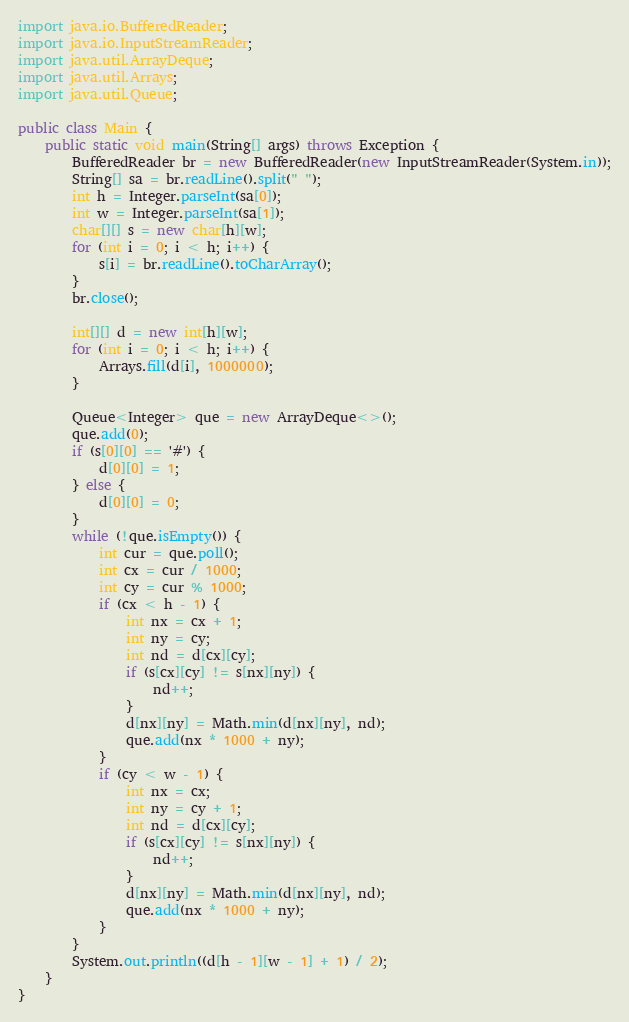Convert code to text. <code><loc_0><loc_0><loc_500><loc_500><_Java_>import java.io.BufferedReader;
import java.io.InputStreamReader;
import java.util.ArrayDeque;
import java.util.Arrays;
import java.util.Queue;

public class Main {
	public static void main(String[] args) throws Exception {
		BufferedReader br = new BufferedReader(new InputStreamReader(System.in));
		String[] sa = br.readLine().split(" ");
		int h = Integer.parseInt(sa[0]);
		int w = Integer.parseInt(sa[1]);
		char[][] s = new char[h][w];
		for (int i = 0; i < h; i++) {
			s[i] = br.readLine().toCharArray();
		}
		br.close();

		int[][] d = new int[h][w];
		for (int i = 0; i < h; i++) {
			Arrays.fill(d[i], 1000000);
		}

		Queue<Integer> que = new ArrayDeque<>();
		que.add(0);
		if (s[0][0] == '#') {
			d[0][0] = 1;
		} else {
			d[0][0] = 0;
		}
		while (!que.isEmpty()) {
			int cur = que.poll();
			int cx = cur / 1000;
			int cy = cur % 1000;
			if (cx < h - 1) {
				int nx = cx + 1;
				int ny = cy;
				int nd = d[cx][cy];
				if (s[cx][cy] != s[nx][ny]) {
					nd++;
				}
				d[nx][ny] = Math.min(d[nx][ny], nd);
				que.add(nx * 1000 + ny);
			}
			if (cy < w - 1) {
				int nx = cx;
				int ny = cy + 1;
				int nd = d[cx][cy];
				if (s[cx][cy] != s[nx][ny]) {
					nd++;
				}
				d[nx][ny] = Math.min(d[nx][ny], nd);
				que.add(nx * 1000 + ny);
			}
		}
		System.out.println((d[h - 1][w - 1] + 1) / 2);
	}
}
</code> 